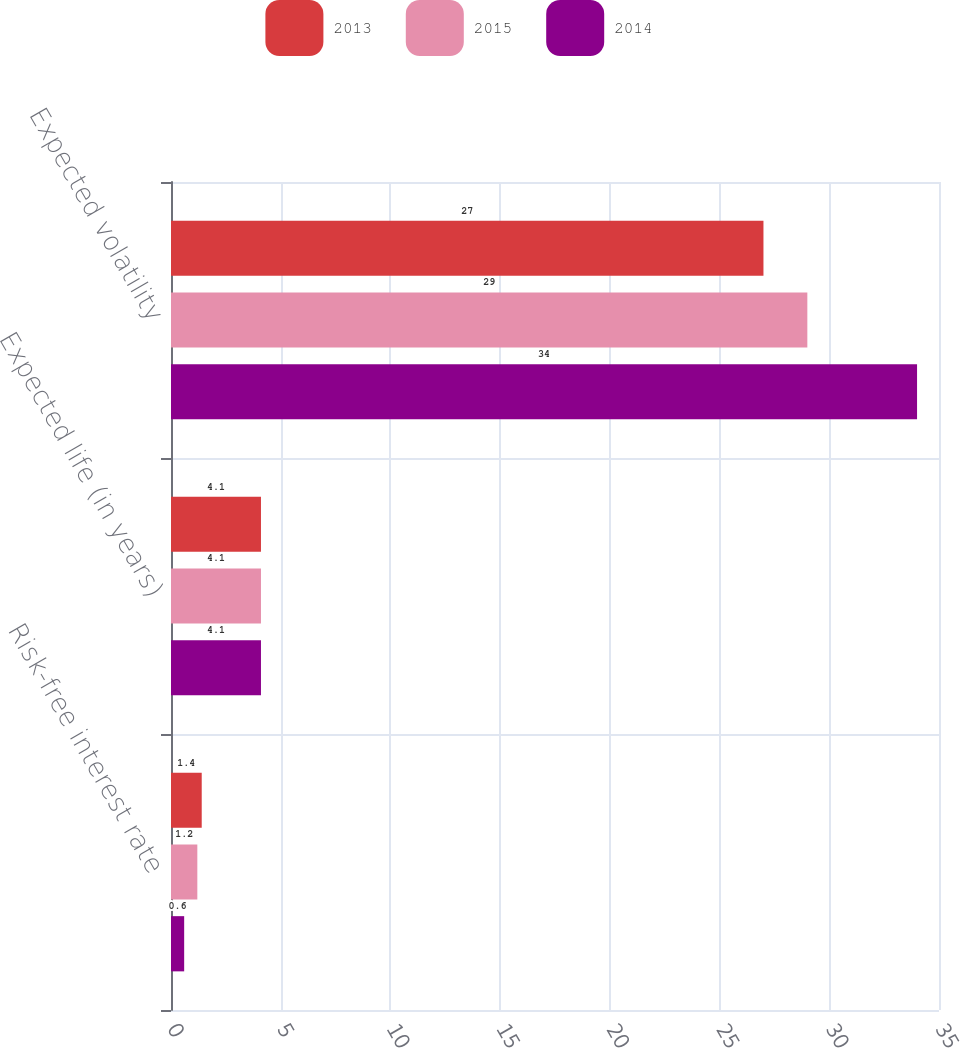Convert chart to OTSL. <chart><loc_0><loc_0><loc_500><loc_500><stacked_bar_chart><ecel><fcel>Risk-free interest rate<fcel>Expected life (in years)<fcel>Expected volatility<nl><fcel>2013<fcel>1.4<fcel>4.1<fcel>27<nl><fcel>2015<fcel>1.2<fcel>4.1<fcel>29<nl><fcel>2014<fcel>0.6<fcel>4.1<fcel>34<nl></chart> 